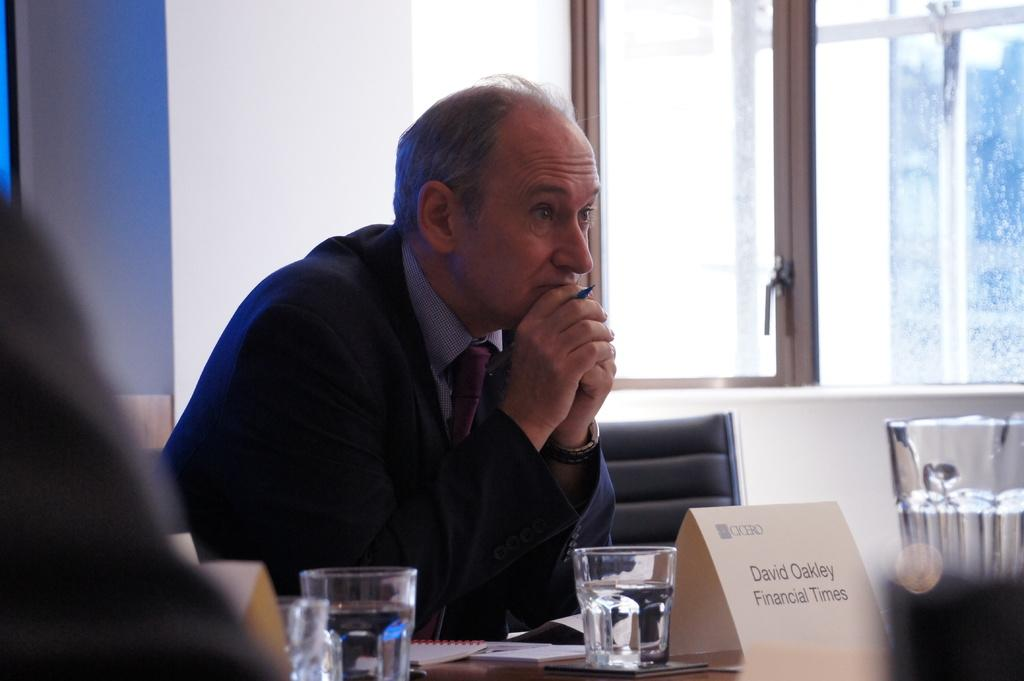<image>
Describe the image concisely. main in suite sitting at a table and card identifying him as david oakley from financial times 